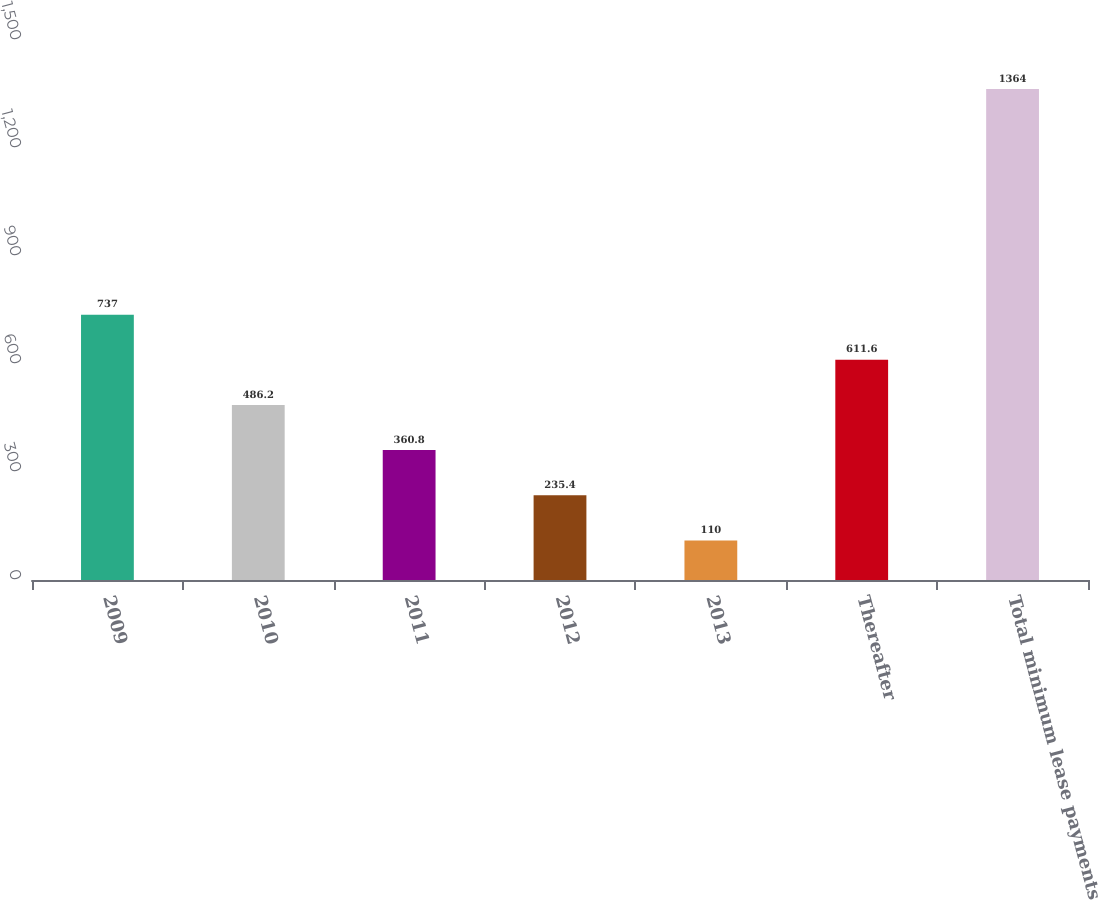Convert chart to OTSL. <chart><loc_0><loc_0><loc_500><loc_500><bar_chart><fcel>2009<fcel>2010<fcel>2011<fcel>2012<fcel>2013<fcel>Thereafter<fcel>Total minimum lease payments<nl><fcel>737<fcel>486.2<fcel>360.8<fcel>235.4<fcel>110<fcel>611.6<fcel>1364<nl></chart> 